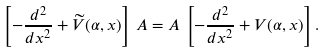Convert formula to latex. <formula><loc_0><loc_0><loc_500><loc_500>\left [ - \frac { d ^ { 2 } } { d x ^ { 2 } } + { \widetilde { V } } ( \alpha , x ) \right ] \, A = A \, \left [ - \frac { d ^ { 2 } } { d x ^ { 2 } } + V ( \alpha , x ) \right ] .</formula> 